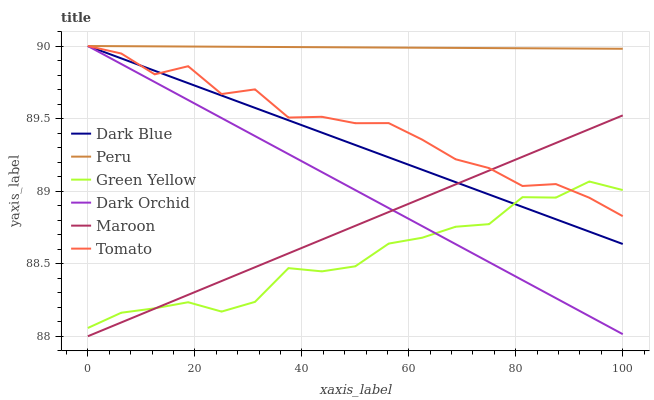Does Green Yellow have the minimum area under the curve?
Answer yes or no. Yes. Does Peru have the maximum area under the curve?
Answer yes or no. Yes. Does Maroon have the minimum area under the curve?
Answer yes or no. No. Does Maroon have the maximum area under the curve?
Answer yes or no. No. Is Dark Orchid the smoothest?
Answer yes or no. Yes. Is Tomato the roughest?
Answer yes or no. Yes. Is Maroon the smoothest?
Answer yes or no. No. Is Maroon the roughest?
Answer yes or no. No. Does Maroon have the lowest value?
Answer yes or no. Yes. Does Dark Blue have the lowest value?
Answer yes or no. No. Does Peru have the highest value?
Answer yes or no. Yes. Does Maroon have the highest value?
Answer yes or no. No. Is Maroon less than Peru?
Answer yes or no. Yes. Is Peru greater than Maroon?
Answer yes or no. Yes. Does Green Yellow intersect Dark Blue?
Answer yes or no. Yes. Is Green Yellow less than Dark Blue?
Answer yes or no. No. Is Green Yellow greater than Dark Blue?
Answer yes or no. No. Does Maroon intersect Peru?
Answer yes or no. No. 